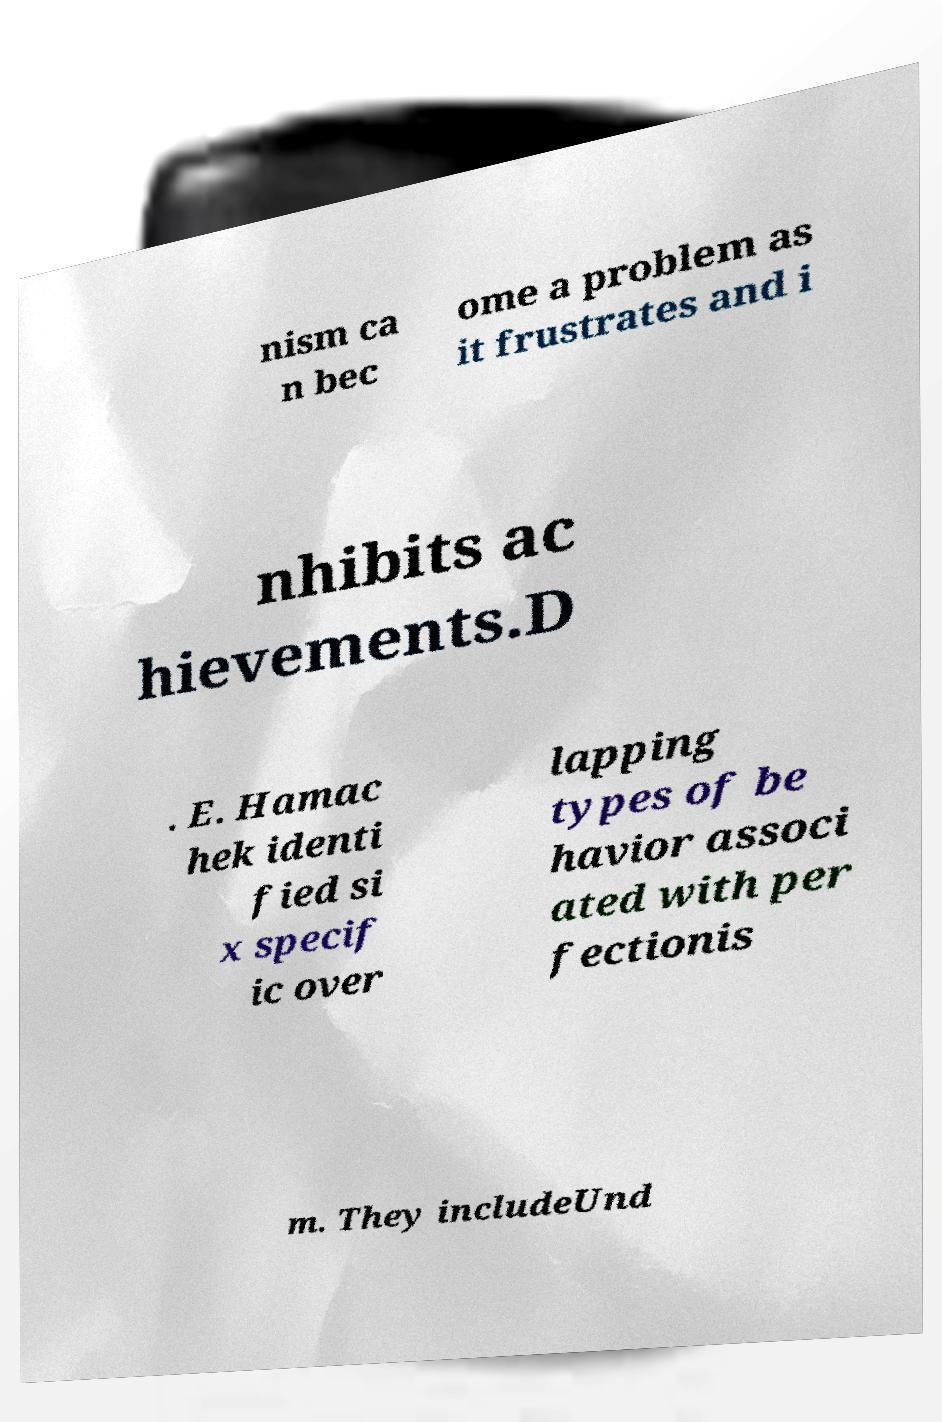I need the written content from this picture converted into text. Can you do that? nism ca n bec ome a problem as it frustrates and i nhibits ac hievements.D . E. Hamac hek identi fied si x specif ic over lapping types of be havior associ ated with per fectionis m. They includeUnd 